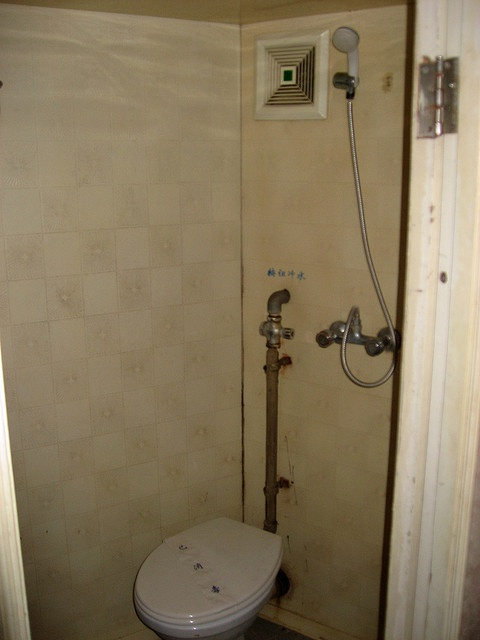Describe the objects in this image and their specific colors. I can see a toilet in black and gray tones in this image. 